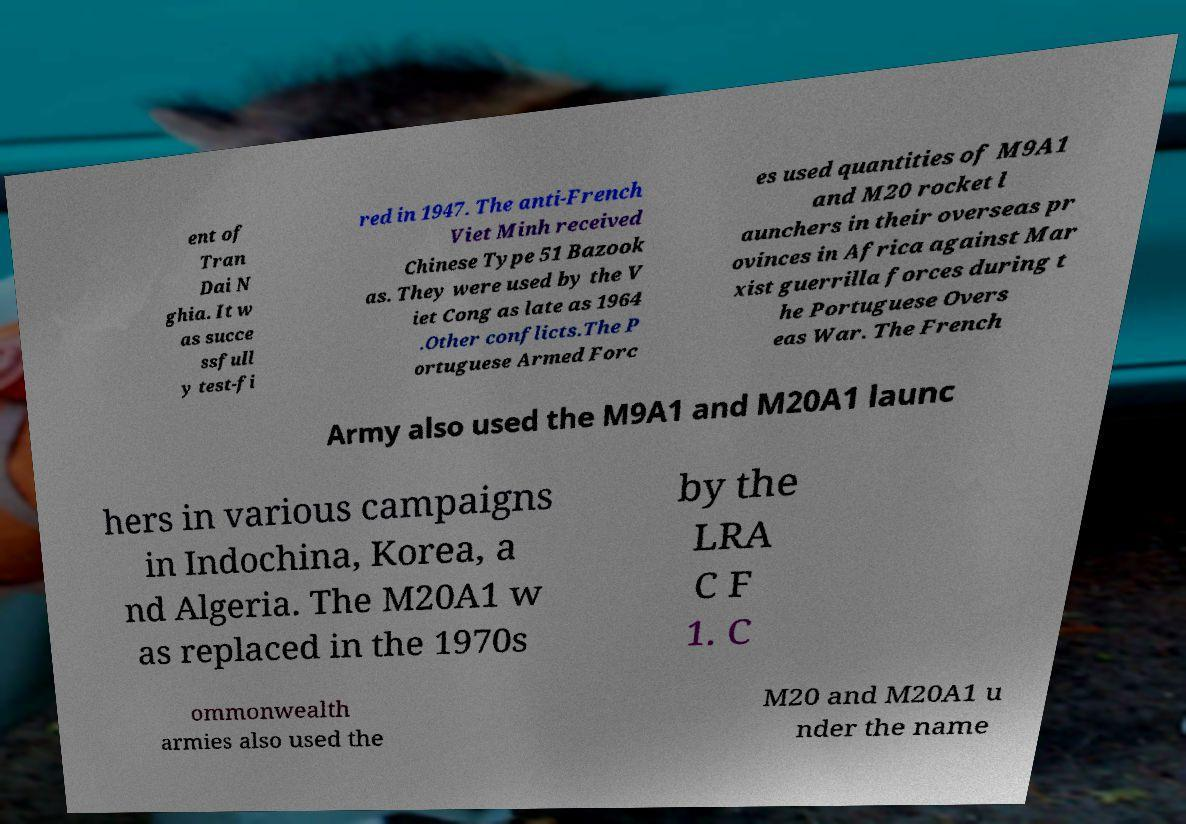Please read and relay the text visible in this image. What does it say? ent of Tran Dai N ghia. It w as succe ssfull y test-fi red in 1947. The anti-French Viet Minh received Chinese Type 51 Bazook as. They were used by the V iet Cong as late as 1964 .Other conflicts.The P ortuguese Armed Forc es used quantities of M9A1 and M20 rocket l aunchers in their overseas pr ovinces in Africa against Mar xist guerrilla forces during t he Portuguese Overs eas War. The French Army also used the M9A1 and M20A1 launc hers in various campaigns in Indochina, Korea, a nd Algeria. The M20A1 w as replaced in the 1970s by the LRA C F 1. C ommonwealth armies also used the M20 and M20A1 u nder the name 